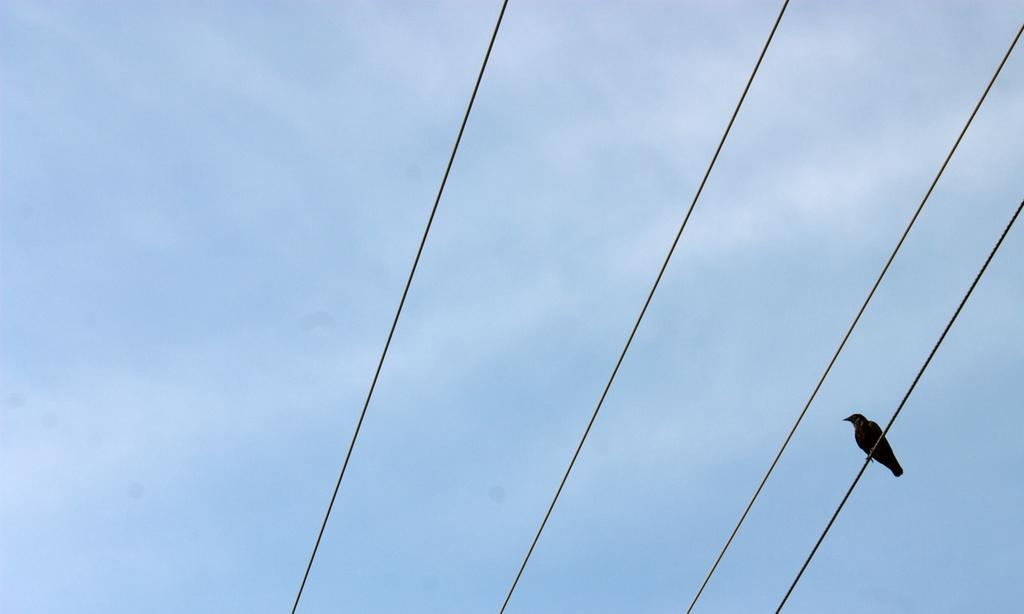What can be seen in the image that is related to electrical infrastructure? There are wires in the image. How are the wires depicted in the image? The wires appear to be truncated. What animal is perched on the wires in the image? There is a bird on the wires. What can be seen in the background of the image? The sky is visible in the background of the image. How is the sky depicted in the image? The sky appears to be truncated. What type of soup is being served in the image? There is no soup present in the image. What value does the bird on the wires represent in the image? The image does not convey any specific values or meanings associated with the bird. 